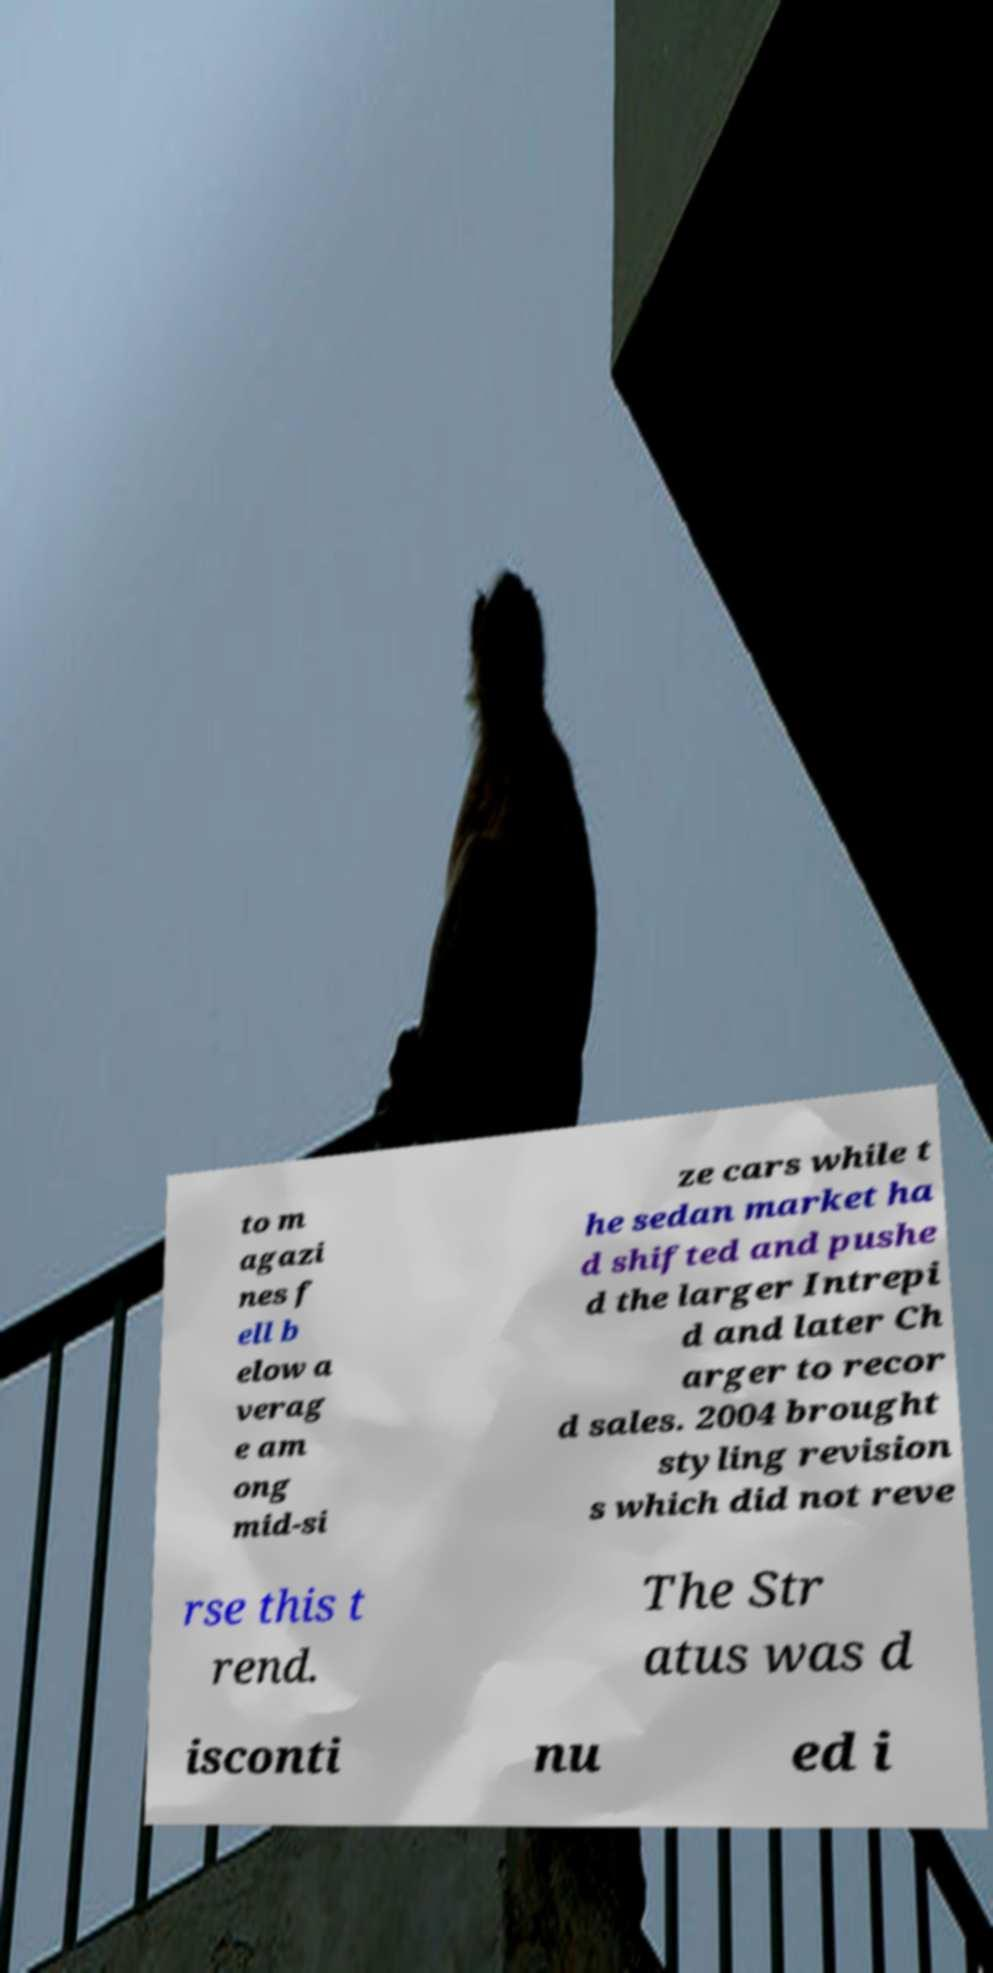Could you assist in decoding the text presented in this image and type it out clearly? to m agazi nes f ell b elow a verag e am ong mid-si ze cars while t he sedan market ha d shifted and pushe d the larger Intrepi d and later Ch arger to recor d sales. 2004 brought styling revision s which did not reve rse this t rend. The Str atus was d isconti nu ed i 